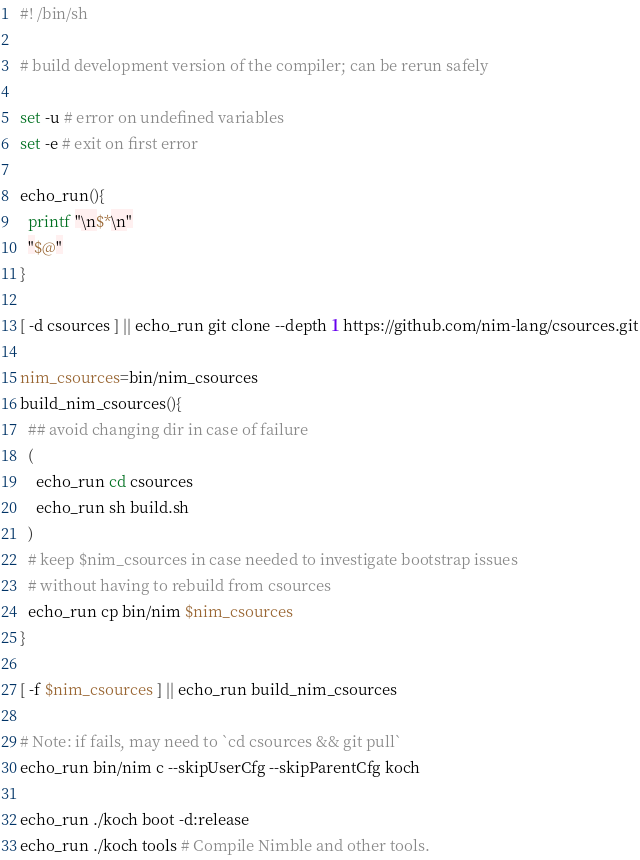<code> <loc_0><loc_0><loc_500><loc_500><_Bash_>#! /bin/sh

# build development version of the compiler; can be rerun safely

set -u # error on undefined variables
set -e # exit on first error

echo_run(){
  printf "\n$*\n"
  "$@"
}

[ -d csources ] || echo_run git clone --depth 1 https://github.com/nim-lang/csources.git

nim_csources=bin/nim_csources
build_nim_csources(){
  ## avoid changing dir in case of failure
  (
    echo_run cd csources
    echo_run sh build.sh
  )
  # keep $nim_csources in case needed to investigate bootstrap issues
  # without having to rebuild from csources
  echo_run cp bin/nim $nim_csources
}

[ -f $nim_csources ] || echo_run build_nim_csources

# Note: if fails, may need to `cd csources && git pull`
echo_run bin/nim c --skipUserCfg --skipParentCfg koch

echo_run ./koch boot -d:release
echo_run ./koch tools # Compile Nimble and other tools.
</code> 